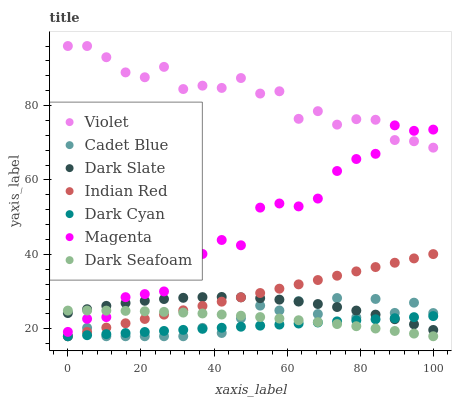Does Dark Cyan have the minimum area under the curve?
Answer yes or no. Yes. Does Violet have the maximum area under the curve?
Answer yes or no. Yes. Does Dark Slate have the minimum area under the curve?
Answer yes or no. No. Does Dark Slate have the maximum area under the curve?
Answer yes or no. No. Is Dark Cyan the smoothest?
Answer yes or no. Yes. Is Magenta the roughest?
Answer yes or no. Yes. Is Dark Slate the smoothest?
Answer yes or no. No. Is Dark Slate the roughest?
Answer yes or no. No. Does Cadet Blue have the lowest value?
Answer yes or no. Yes. Does Dark Slate have the lowest value?
Answer yes or no. No. Does Violet have the highest value?
Answer yes or no. Yes. Does Dark Slate have the highest value?
Answer yes or no. No. Is Dark Seafoam less than Violet?
Answer yes or no. Yes. Is Violet greater than Indian Red?
Answer yes or no. Yes. Does Dark Slate intersect Dark Seafoam?
Answer yes or no. Yes. Is Dark Slate less than Dark Seafoam?
Answer yes or no. No. Is Dark Slate greater than Dark Seafoam?
Answer yes or no. No. Does Dark Seafoam intersect Violet?
Answer yes or no. No. 